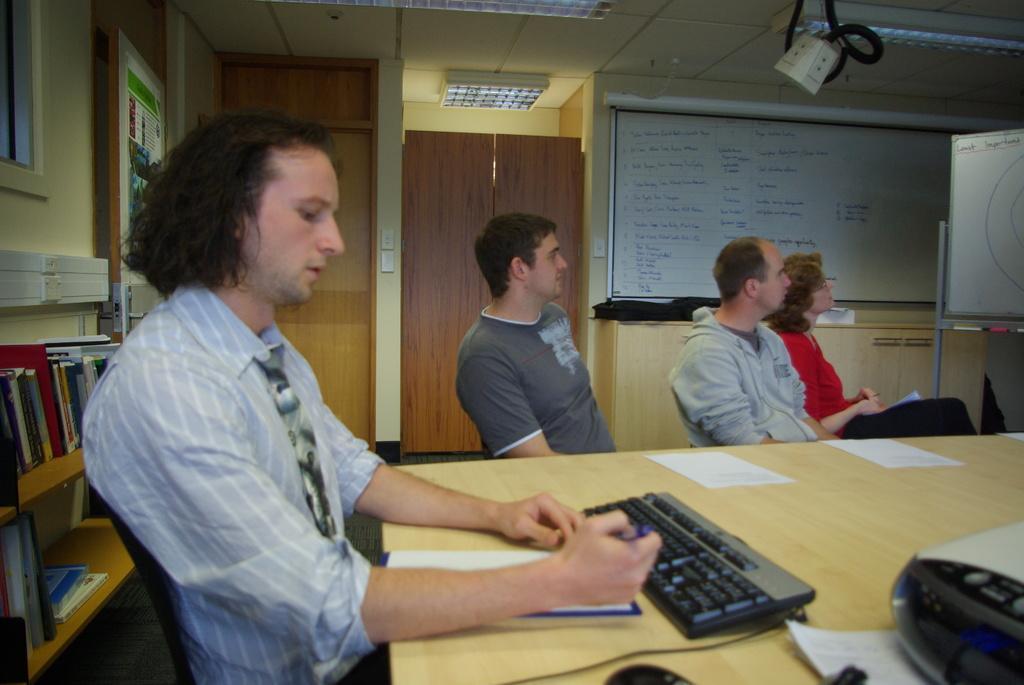Could you give a brief overview of what you see in this image? This picture might be taken inside the room. In this image, on the left side, we can see a man sitting on the chair in front of the table and he is also holding a pen in his hand. On the left side, we can see some books on the shelf. In the middle and on the right side, we can see three people are sitting on the chair in front of the table, on that table, we can see a key board, electrical wire, mouse, papers, electronic machine. On right side there is a white color board. In the background, we can also see a board and a door. On the top, we can see a projector and roof with few lights. 